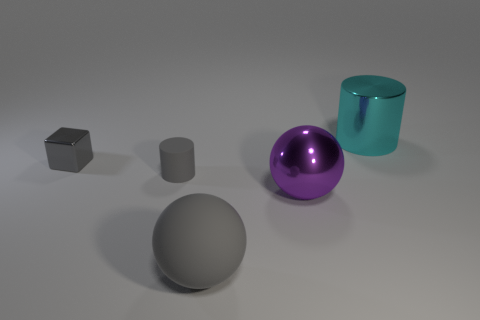There is a cylinder on the left side of the large gray rubber thing; does it have the same color as the metal block? The cylinder to the left of the large gray object appears to have a slightly different hue and glossy finish compared to the metal block. The metallic block has a darker, more matte surface, indicating their colors are not exactly the same. 